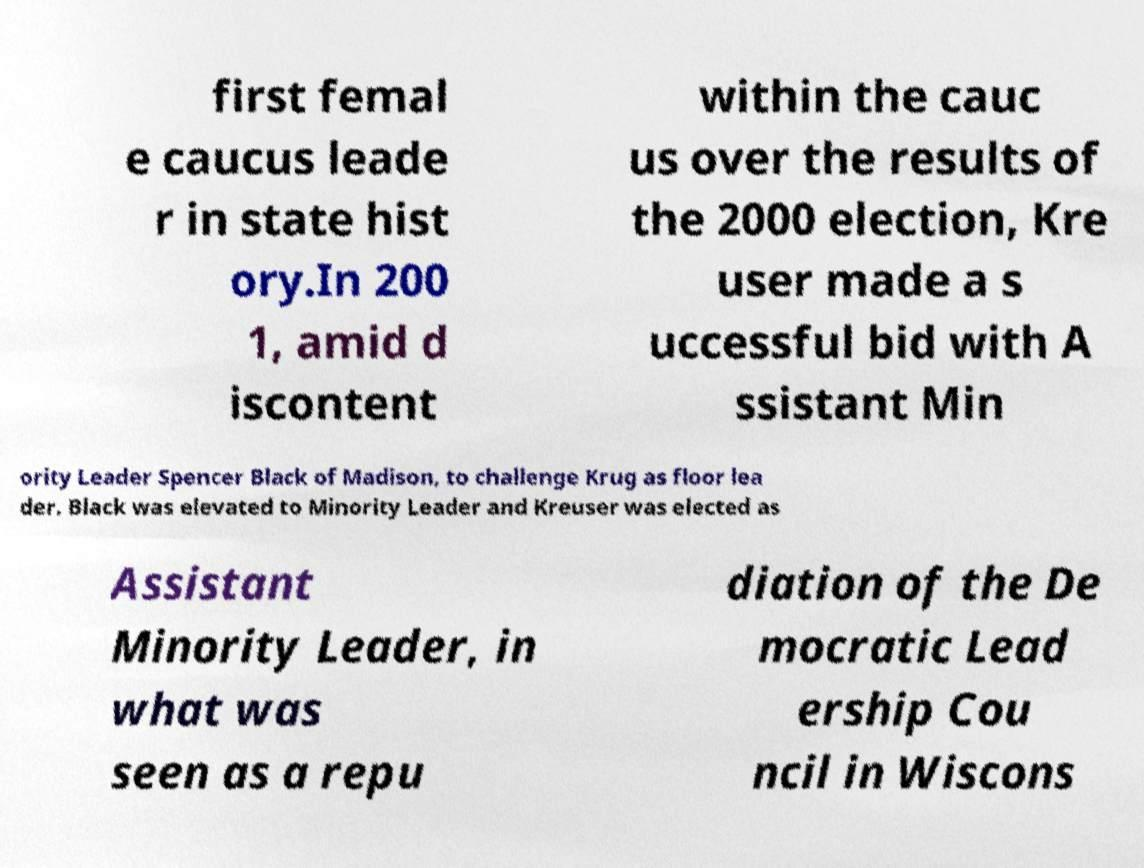Can you read and provide the text displayed in the image?This photo seems to have some interesting text. Can you extract and type it out for me? first femal e caucus leade r in state hist ory.In 200 1, amid d iscontent within the cauc us over the results of the 2000 election, Kre user made a s uccessful bid with A ssistant Min ority Leader Spencer Black of Madison, to challenge Krug as floor lea der. Black was elevated to Minority Leader and Kreuser was elected as Assistant Minority Leader, in what was seen as a repu diation of the De mocratic Lead ership Cou ncil in Wiscons 